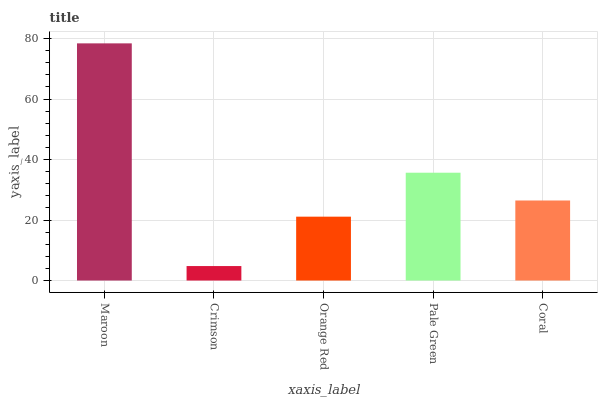Is Crimson the minimum?
Answer yes or no. Yes. Is Maroon the maximum?
Answer yes or no. Yes. Is Orange Red the minimum?
Answer yes or no. No. Is Orange Red the maximum?
Answer yes or no. No. Is Orange Red greater than Crimson?
Answer yes or no. Yes. Is Crimson less than Orange Red?
Answer yes or no. Yes. Is Crimson greater than Orange Red?
Answer yes or no. No. Is Orange Red less than Crimson?
Answer yes or no. No. Is Coral the high median?
Answer yes or no. Yes. Is Coral the low median?
Answer yes or no. Yes. Is Orange Red the high median?
Answer yes or no. No. Is Pale Green the low median?
Answer yes or no. No. 